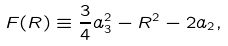<formula> <loc_0><loc_0><loc_500><loc_500>F ( R ) \equiv \frac { 3 } { 4 } a _ { 3 } ^ { 2 } - R ^ { 2 } - 2 a _ { 2 } ,</formula> 